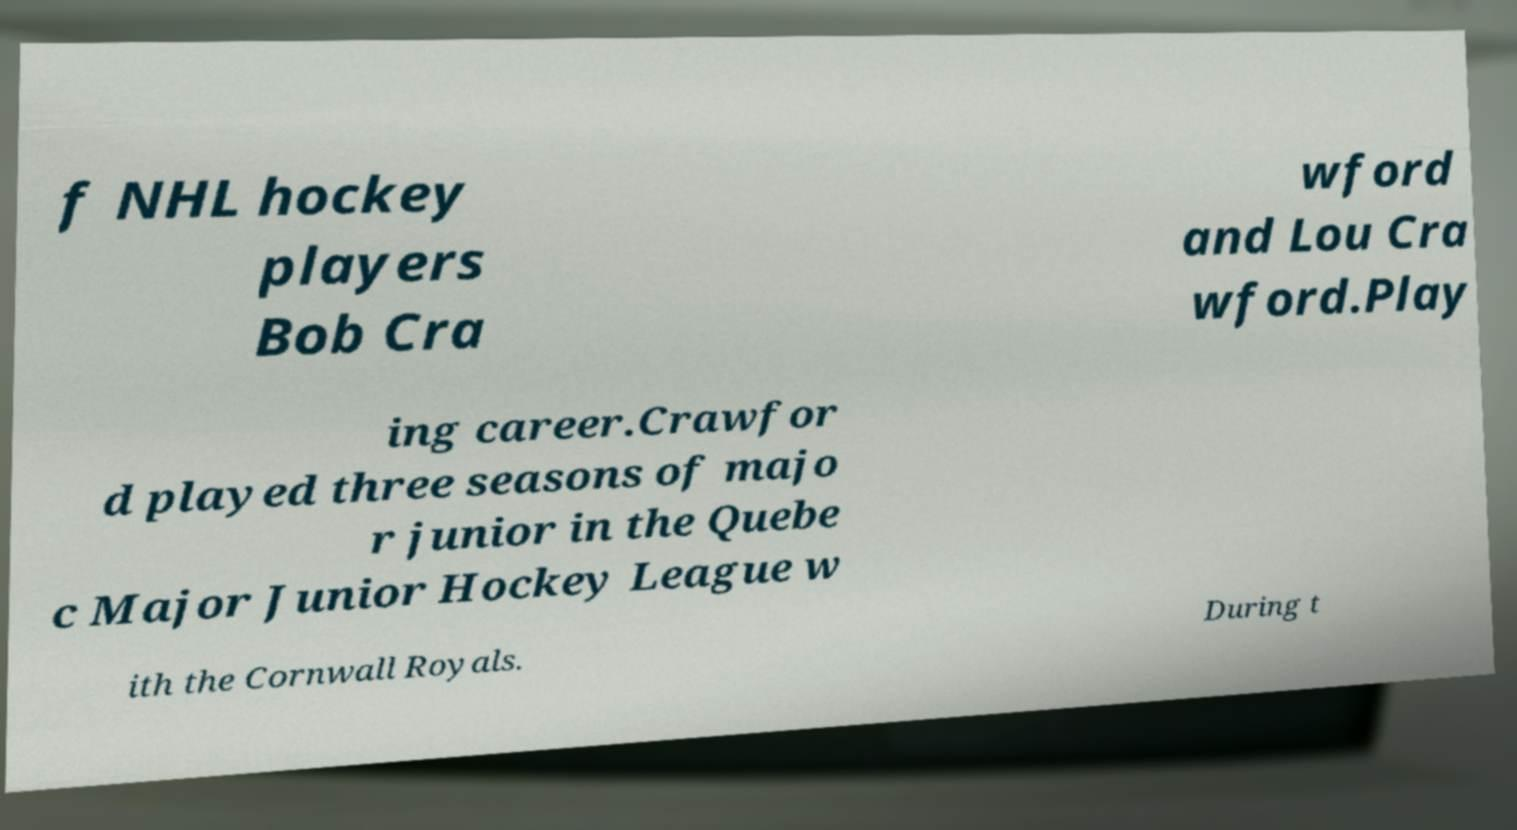What messages or text are displayed in this image? I need them in a readable, typed format. f NHL hockey players Bob Cra wford and Lou Cra wford.Play ing career.Crawfor d played three seasons of majo r junior in the Quebe c Major Junior Hockey League w ith the Cornwall Royals. During t 